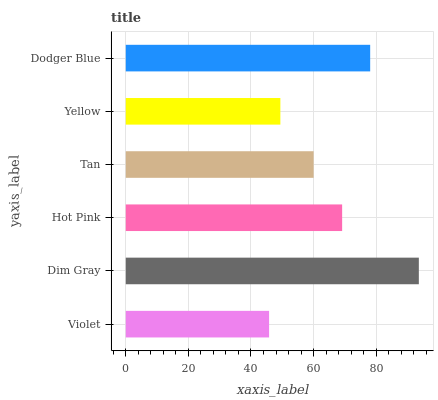Is Violet the minimum?
Answer yes or no. Yes. Is Dim Gray the maximum?
Answer yes or no. Yes. Is Hot Pink the minimum?
Answer yes or no. No. Is Hot Pink the maximum?
Answer yes or no. No. Is Dim Gray greater than Hot Pink?
Answer yes or no. Yes. Is Hot Pink less than Dim Gray?
Answer yes or no. Yes. Is Hot Pink greater than Dim Gray?
Answer yes or no. No. Is Dim Gray less than Hot Pink?
Answer yes or no. No. Is Hot Pink the high median?
Answer yes or no. Yes. Is Tan the low median?
Answer yes or no. Yes. Is Dodger Blue the high median?
Answer yes or no. No. Is Violet the low median?
Answer yes or no. No. 